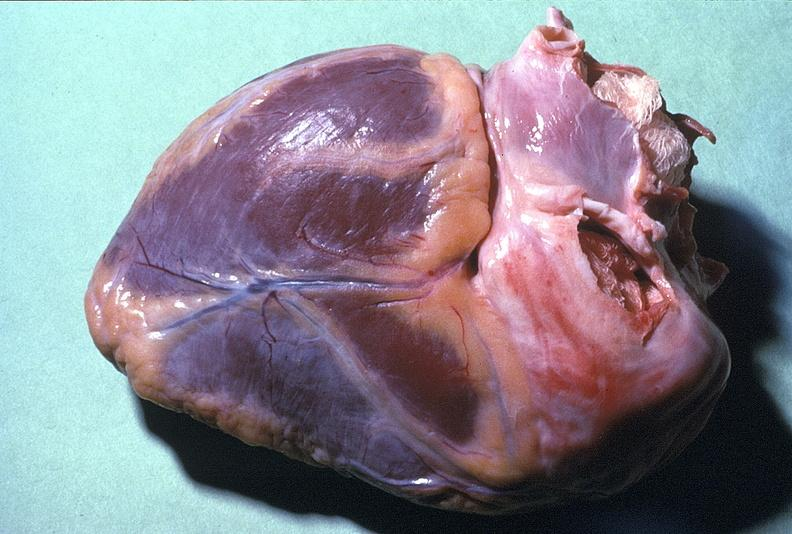does this image show normal duct in postmenopausal woman?
Answer the question using a single word or phrase. Yes 